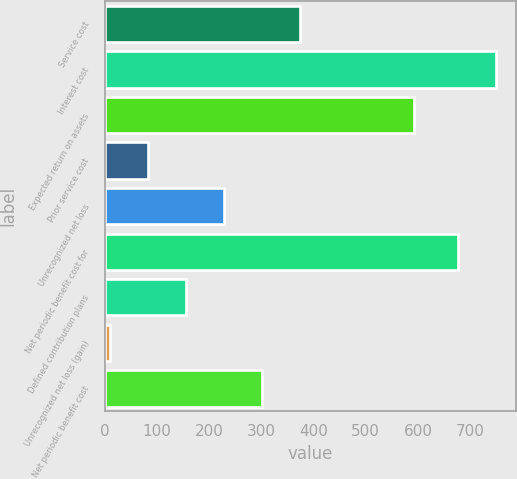<chart> <loc_0><loc_0><loc_500><loc_500><bar_chart><fcel>Service cost<fcel>Interest cost<fcel>Expected return on assets<fcel>Prior service cost<fcel>Unrecognized net loss<fcel>Net periodic benefit cost for<fcel>Defined contribution plans<fcel>Unrecognized net loss (gain)<fcel>Net periodic benefit cost<nl><fcel>373.5<fcel>749.7<fcel>593<fcel>82.7<fcel>228.1<fcel>677<fcel>155.4<fcel>10<fcel>300.8<nl></chart> 